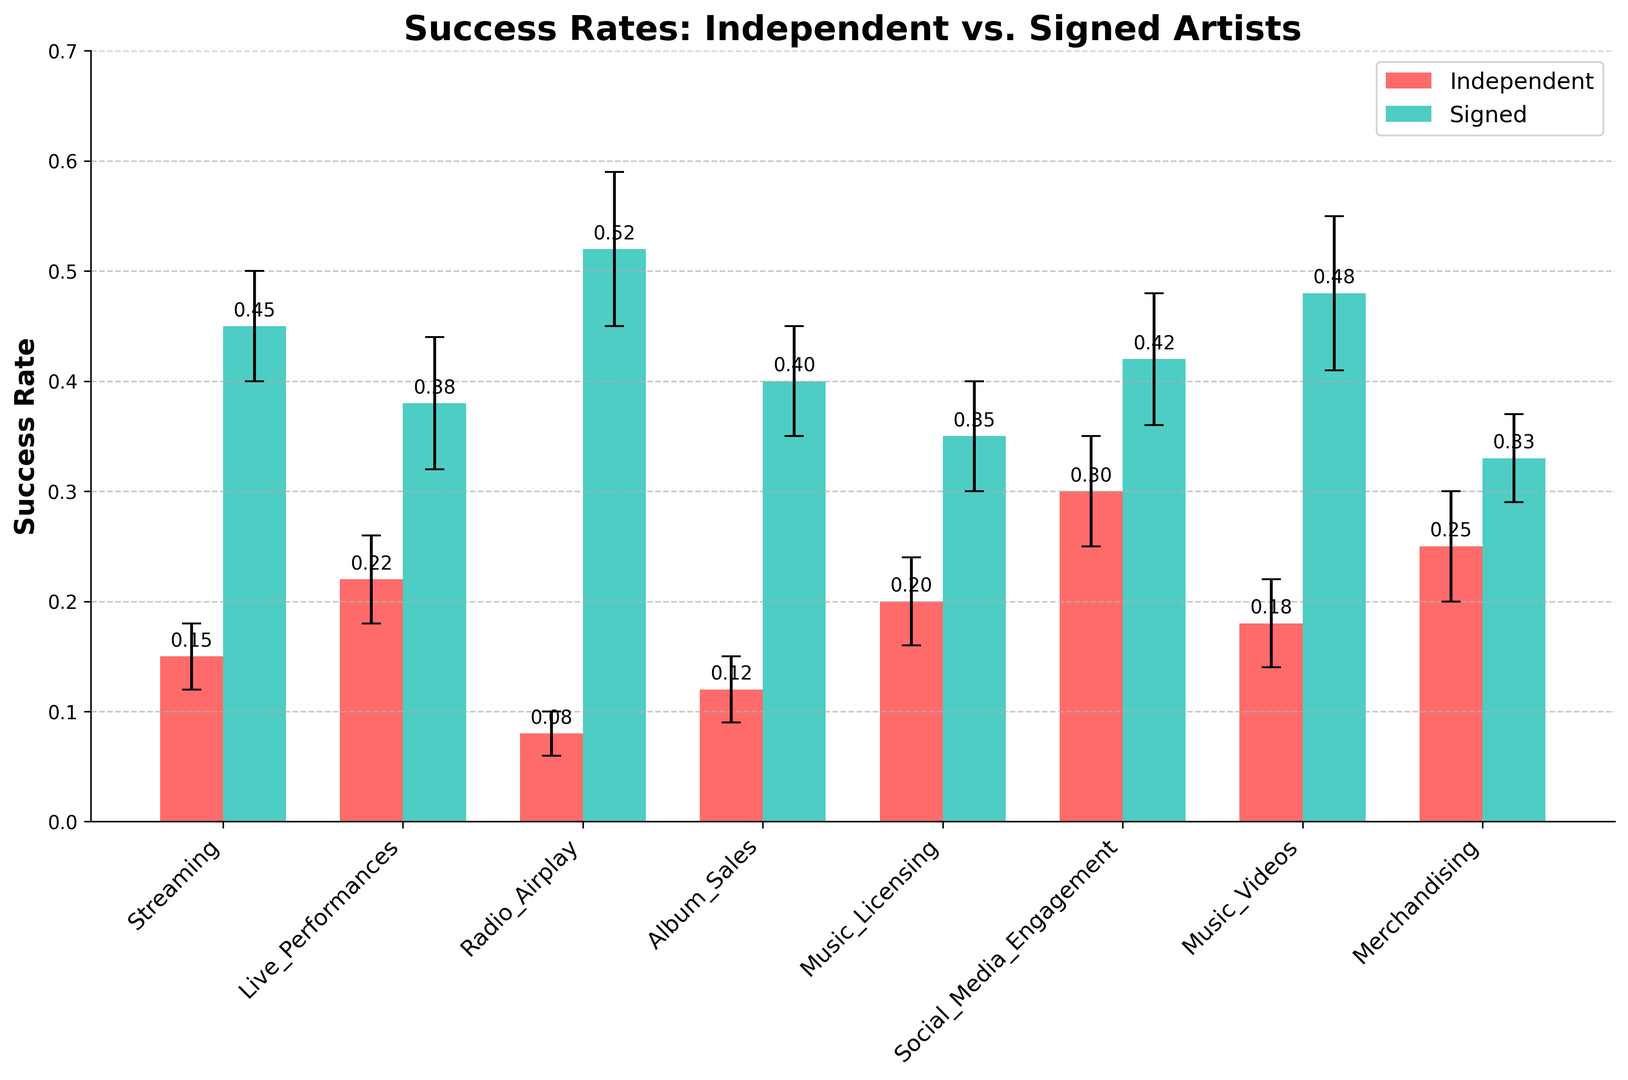What is the success rate of independent artists in the streaming market? The bar representing independent artists in the streaming market has a height of 0.15, indicating their success rate.
Answer: 0.15 Which artist type has a higher success rate in the live performances market? The bar for signed artists in the live performances market is taller than the one for independent artists, with success rates of 0.38 and 0.22, respectively.
Answer: Signed By how much does the success rate of signed artists in radio airplay exceed that of independent artists? The success rate for independent artists in radio airplay is 0.08, while for signed artists it is 0.52. The difference is 0.52 - 0.08.
Answer: 0.44 In which market do independent artists have their highest success rate? Among all markets, the bar for the social media engagement market has the highest height for independent artists, indicating a success rate of 0.30.
Answer: Social Media Engagement What is the error margin for signed artists in the music videos market? The error bar atop the bar for signed artists in the music videos market has a vertical distance of 0.07.
Answer: 0.07 Compare the success rates of independent and signed artists in the album sales market and determine the percentage point difference. Independent artists have a success rate of 0.12, while signed artists have 0.40 in album sales. The percentage point difference is 0.40 - 0.12.
Answer: 28 percentage points Which market shows the smallest success rate difference between independent and signed artists? The smallest difference can be calculated by comparing differences in all markets. The smallest difference appears in the music licensing market, with success rates of 0.20 for independent and 0.35 for signed, resulting in a difference of 0.15.
Answer: Music Licensing In which market do signed artists have the lowest success rate, and what is that rate? Among all markets, signed artists have the lowest bar in the merchandising market, with a success rate of 0.33.
Answer: Merchandising What are the error margins for independent artists in the social media engagement and merchandising markets? The error bar for independent artists in social media engagement is 0.05, and in merchandising, it is also 0.05.
Answer: 0.05 and 0.05 